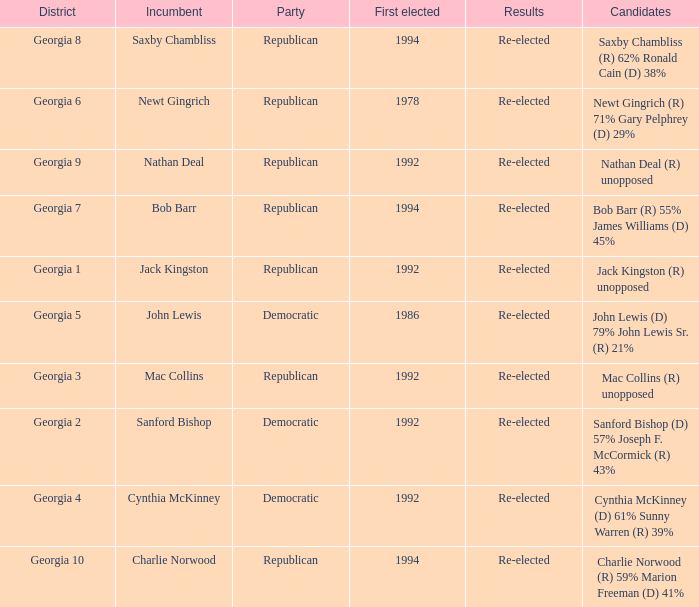Who were the candidates in the election where Saxby Chambliss was the incumbent? Saxby Chambliss (R) 62% Ronald Cain (D) 38%. Give me the full table as a dictionary. {'header': ['District', 'Incumbent', 'Party', 'First elected', 'Results', 'Candidates'], 'rows': [['Georgia 8', 'Saxby Chambliss', 'Republican', '1994', 'Re-elected', 'Saxby Chambliss (R) 62% Ronald Cain (D) 38%'], ['Georgia 6', 'Newt Gingrich', 'Republican', '1978', 'Re-elected', 'Newt Gingrich (R) 71% Gary Pelphrey (D) 29%'], ['Georgia 9', 'Nathan Deal', 'Republican', '1992', 'Re-elected', 'Nathan Deal (R) unopposed'], ['Georgia 7', 'Bob Barr', 'Republican', '1994', 'Re-elected', 'Bob Barr (R) 55% James Williams (D) 45%'], ['Georgia 1', 'Jack Kingston', 'Republican', '1992', 'Re-elected', 'Jack Kingston (R) unopposed'], ['Georgia 5', 'John Lewis', 'Democratic', '1986', 'Re-elected', 'John Lewis (D) 79% John Lewis Sr. (R) 21%'], ['Georgia 3', 'Mac Collins', 'Republican', '1992', 'Re-elected', 'Mac Collins (R) unopposed'], ['Georgia 2', 'Sanford Bishop', 'Democratic', '1992', 'Re-elected', 'Sanford Bishop (D) 57% Joseph F. McCormick (R) 43%'], ['Georgia 4', 'Cynthia McKinney', 'Democratic', '1992', 'Re-elected', 'Cynthia McKinney (D) 61% Sunny Warren (R) 39%'], ['Georgia 10', 'Charlie Norwood', 'Republican', '1994', 'Re-elected', 'Charlie Norwood (R) 59% Marion Freeman (D) 41%']]} 